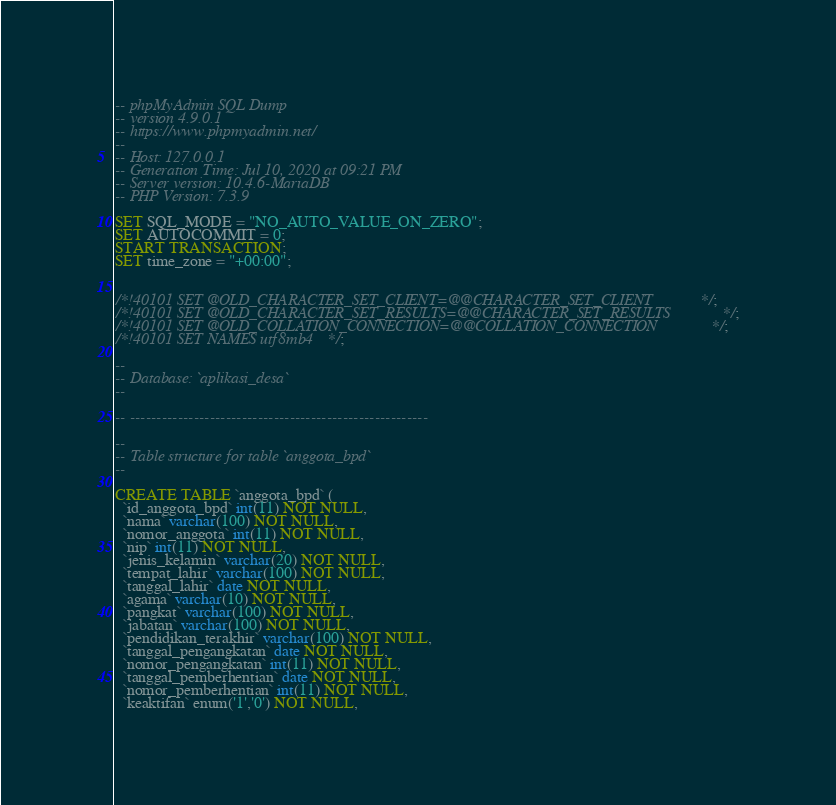<code> <loc_0><loc_0><loc_500><loc_500><_SQL_>-- phpMyAdmin SQL Dump
-- version 4.9.0.1
-- https://www.phpmyadmin.net/
--
-- Host: 127.0.0.1
-- Generation Time: Jul 10, 2020 at 09:21 PM
-- Server version: 10.4.6-MariaDB
-- PHP Version: 7.3.9

SET SQL_MODE = "NO_AUTO_VALUE_ON_ZERO";
SET AUTOCOMMIT = 0;
START TRANSACTION;
SET time_zone = "+00:00";


/*!40101 SET @OLD_CHARACTER_SET_CLIENT=@@CHARACTER_SET_CLIENT */;
/*!40101 SET @OLD_CHARACTER_SET_RESULTS=@@CHARACTER_SET_RESULTS */;
/*!40101 SET @OLD_COLLATION_CONNECTION=@@COLLATION_CONNECTION */;
/*!40101 SET NAMES utf8mb4 */;

--
-- Database: `aplikasi_desa`
--

-- --------------------------------------------------------

--
-- Table structure for table `anggota_bpd`
--

CREATE TABLE `anggota_bpd` (
  `id_anggota_bpd` int(11) NOT NULL,
  `nama` varchar(100) NOT NULL,
  `nomor_anggota` int(11) NOT NULL,
  `nip` int(11) NOT NULL,
  `jenis_kelamin` varchar(20) NOT NULL,
  `tempat_lahir` varchar(100) NOT NULL,
  `tanggal_lahir` date NOT NULL,
  `agama` varchar(10) NOT NULL,
  `pangkat` varchar(100) NOT NULL,
  `jabatan` varchar(100) NOT NULL,
  `pendidikan_terakhir` varchar(100) NOT NULL,
  `tanggal_pengangkatan` date NOT NULL,
  `nomor_pengangkatan` int(11) NOT NULL,
  `tanggal_pemberhentian` date NOT NULL,
  `nomor_pemberhentian` int(11) NOT NULL,
  `keaktifan` enum('1','0') NOT NULL,</code> 